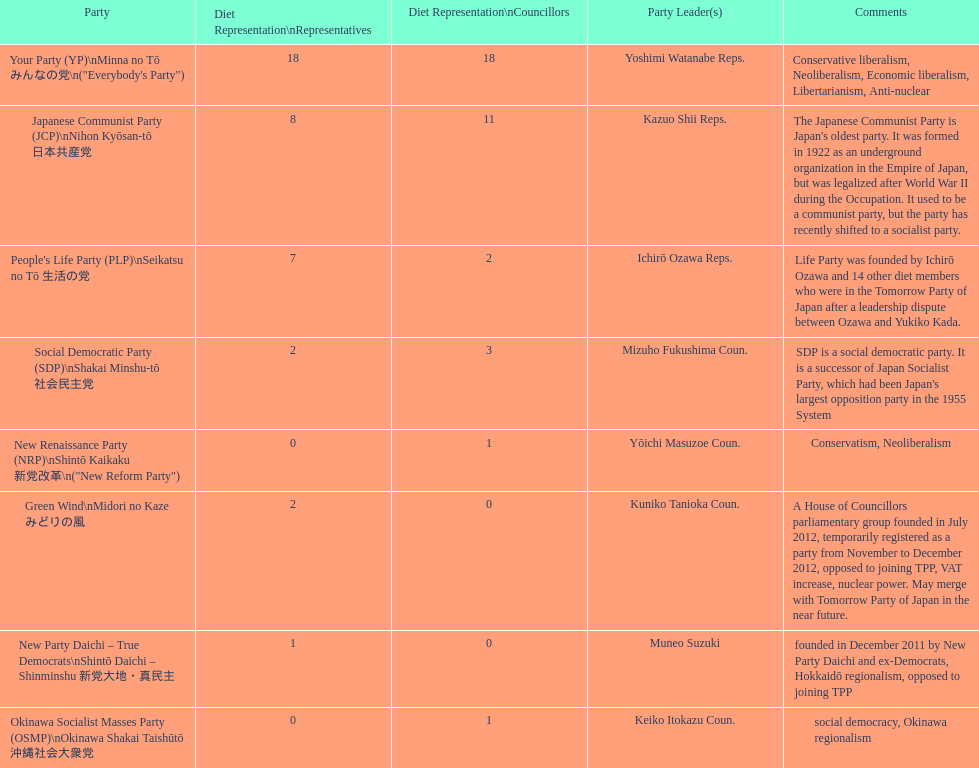What party has the most representatives in the diet representation? Your Party. 